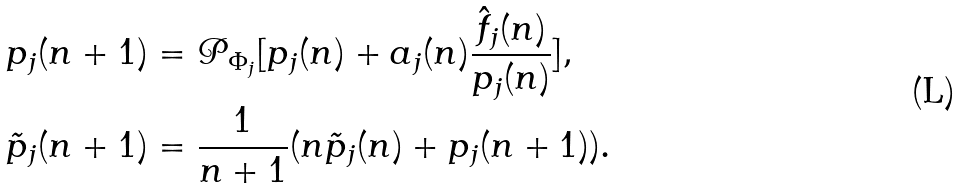<formula> <loc_0><loc_0><loc_500><loc_500>p _ { j } ( n + 1 ) & = \mathcal { P } _ { \Phi _ { j } } [ p _ { j } ( n ) + a _ { j } ( n ) \frac { \hat { f } _ { j } ( n ) } { p _ { j } ( n ) } ] , \\ \tilde { p } _ { j } ( n + 1 ) & = \frac { 1 } { n + 1 } ( n \tilde { p } _ { j } ( n ) + p _ { j } ( n + 1 ) ) .</formula> 